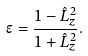Convert formula to latex. <formula><loc_0><loc_0><loc_500><loc_500>\epsilon = \frac { 1 - \hat { L } _ { z } ^ { 2 } } { 1 + \hat { L } _ { z } ^ { 2 } } .</formula> 